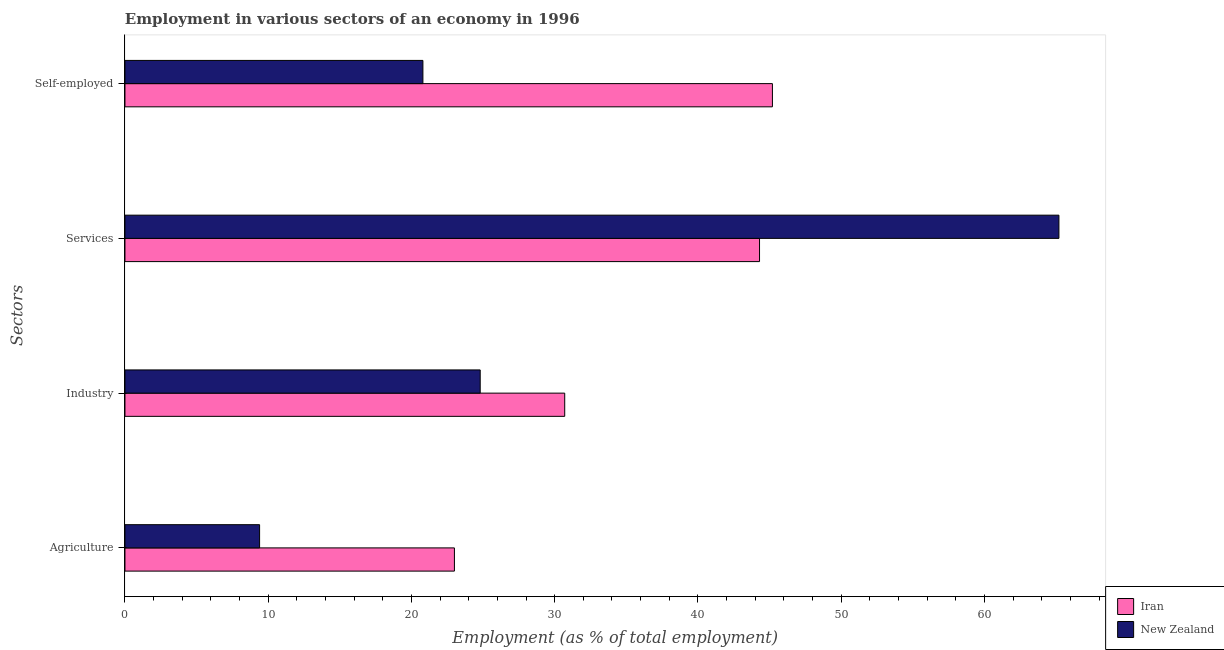How many groups of bars are there?
Give a very brief answer. 4. Are the number of bars per tick equal to the number of legend labels?
Provide a succinct answer. Yes. Are the number of bars on each tick of the Y-axis equal?
Your answer should be very brief. Yes. How many bars are there on the 3rd tick from the top?
Provide a succinct answer. 2. What is the label of the 1st group of bars from the top?
Make the answer very short. Self-employed. What is the percentage of workers in industry in New Zealand?
Your answer should be very brief. 24.8. Across all countries, what is the maximum percentage of workers in services?
Make the answer very short. 65.2. Across all countries, what is the minimum percentage of workers in services?
Provide a short and direct response. 44.3. In which country was the percentage of workers in industry maximum?
Offer a terse response. Iran. In which country was the percentage of workers in industry minimum?
Your response must be concise. New Zealand. What is the total percentage of workers in agriculture in the graph?
Your answer should be very brief. 32.4. What is the difference between the percentage of workers in agriculture in New Zealand and that in Iran?
Make the answer very short. -13.6. What is the difference between the percentage of workers in services in New Zealand and the percentage of workers in agriculture in Iran?
Offer a terse response. 42.2. What is the average percentage of workers in services per country?
Offer a very short reply. 54.75. What is the difference between the percentage of workers in industry and percentage of self employed workers in Iran?
Keep it short and to the point. -14.5. What is the ratio of the percentage of workers in services in New Zealand to that in Iran?
Provide a short and direct response. 1.47. Is the percentage of workers in industry in Iran less than that in New Zealand?
Offer a very short reply. No. Is the difference between the percentage of workers in services in Iran and New Zealand greater than the difference between the percentage of workers in agriculture in Iran and New Zealand?
Provide a short and direct response. No. What is the difference between the highest and the second highest percentage of workers in industry?
Your answer should be very brief. 5.9. What is the difference between the highest and the lowest percentage of workers in industry?
Your answer should be compact. 5.9. In how many countries, is the percentage of workers in industry greater than the average percentage of workers in industry taken over all countries?
Ensure brevity in your answer.  1. Is the sum of the percentage of self employed workers in Iran and New Zealand greater than the maximum percentage of workers in industry across all countries?
Give a very brief answer. Yes. What does the 2nd bar from the top in Industry represents?
Provide a short and direct response. Iran. What does the 2nd bar from the bottom in Industry represents?
Keep it short and to the point. New Zealand. How many bars are there?
Ensure brevity in your answer.  8. Are all the bars in the graph horizontal?
Ensure brevity in your answer.  Yes. What is the difference between two consecutive major ticks on the X-axis?
Keep it short and to the point. 10. Are the values on the major ticks of X-axis written in scientific E-notation?
Provide a short and direct response. No. Where does the legend appear in the graph?
Offer a terse response. Bottom right. How many legend labels are there?
Ensure brevity in your answer.  2. What is the title of the graph?
Ensure brevity in your answer.  Employment in various sectors of an economy in 1996. Does "Costa Rica" appear as one of the legend labels in the graph?
Your answer should be very brief. No. What is the label or title of the X-axis?
Make the answer very short. Employment (as % of total employment). What is the label or title of the Y-axis?
Make the answer very short. Sectors. What is the Employment (as % of total employment) in New Zealand in Agriculture?
Your answer should be compact. 9.4. What is the Employment (as % of total employment) in Iran in Industry?
Your response must be concise. 30.7. What is the Employment (as % of total employment) of New Zealand in Industry?
Your answer should be very brief. 24.8. What is the Employment (as % of total employment) in Iran in Services?
Your answer should be compact. 44.3. What is the Employment (as % of total employment) in New Zealand in Services?
Your answer should be very brief. 65.2. What is the Employment (as % of total employment) of Iran in Self-employed?
Offer a terse response. 45.2. What is the Employment (as % of total employment) of New Zealand in Self-employed?
Keep it short and to the point. 20.8. Across all Sectors, what is the maximum Employment (as % of total employment) in Iran?
Offer a terse response. 45.2. Across all Sectors, what is the maximum Employment (as % of total employment) of New Zealand?
Provide a short and direct response. 65.2. Across all Sectors, what is the minimum Employment (as % of total employment) in New Zealand?
Your answer should be compact. 9.4. What is the total Employment (as % of total employment) in Iran in the graph?
Offer a terse response. 143.2. What is the total Employment (as % of total employment) of New Zealand in the graph?
Offer a terse response. 120.2. What is the difference between the Employment (as % of total employment) of New Zealand in Agriculture and that in Industry?
Ensure brevity in your answer.  -15.4. What is the difference between the Employment (as % of total employment) in Iran in Agriculture and that in Services?
Make the answer very short. -21.3. What is the difference between the Employment (as % of total employment) in New Zealand in Agriculture and that in Services?
Give a very brief answer. -55.8. What is the difference between the Employment (as % of total employment) of Iran in Agriculture and that in Self-employed?
Offer a very short reply. -22.2. What is the difference between the Employment (as % of total employment) in New Zealand in Agriculture and that in Self-employed?
Provide a succinct answer. -11.4. What is the difference between the Employment (as % of total employment) of New Zealand in Industry and that in Services?
Offer a very short reply. -40.4. What is the difference between the Employment (as % of total employment) of Iran in Industry and that in Self-employed?
Your response must be concise. -14.5. What is the difference between the Employment (as % of total employment) of Iran in Services and that in Self-employed?
Your response must be concise. -0.9. What is the difference between the Employment (as % of total employment) of New Zealand in Services and that in Self-employed?
Offer a very short reply. 44.4. What is the difference between the Employment (as % of total employment) of Iran in Agriculture and the Employment (as % of total employment) of New Zealand in Services?
Your answer should be compact. -42.2. What is the difference between the Employment (as % of total employment) in Iran in Agriculture and the Employment (as % of total employment) in New Zealand in Self-employed?
Provide a succinct answer. 2.2. What is the difference between the Employment (as % of total employment) in Iran in Industry and the Employment (as % of total employment) in New Zealand in Services?
Ensure brevity in your answer.  -34.5. What is the difference between the Employment (as % of total employment) in Iran in Services and the Employment (as % of total employment) in New Zealand in Self-employed?
Make the answer very short. 23.5. What is the average Employment (as % of total employment) of Iran per Sectors?
Give a very brief answer. 35.8. What is the average Employment (as % of total employment) in New Zealand per Sectors?
Make the answer very short. 30.05. What is the difference between the Employment (as % of total employment) of Iran and Employment (as % of total employment) of New Zealand in Agriculture?
Your answer should be compact. 13.6. What is the difference between the Employment (as % of total employment) in Iran and Employment (as % of total employment) in New Zealand in Services?
Give a very brief answer. -20.9. What is the difference between the Employment (as % of total employment) in Iran and Employment (as % of total employment) in New Zealand in Self-employed?
Ensure brevity in your answer.  24.4. What is the ratio of the Employment (as % of total employment) of Iran in Agriculture to that in Industry?
Make the answer very short. 0.75. What is the ratio of the Employment (as % of total employment) in New Zealand in Agriculture to that in Industry?
Provide a short and direct response. 0.38. What is the ratio of the Employment (as % of total employment) in Iran in Agriculture to that in Services?
Your response must be concise. 0.52. What is the ratio of the Employment (as % of total employment) of New Zealand in Agriculture to that in Services?
Offer a terse response. 0.14. What is the ratio of the Employment (as % of total employment) in Iran in Agriculture to that in Self-employed?
Provide a succinct answer. 0.51. What is the ratio of the Employment (as % of total employment) in New Zealand in Agriculture to that in Self-employed?
Keep it short and to the point. 0.45. What is the ratio of the Employment (as % of total employment) of Iran in Industry to that in Services?
Keep it short and to the point. 0.69. What is the ratio of the Employment (as % of total employment) in New Zealand in Industry to that in Services?
Provide a short and direct response. 0.38. What is the ratio of the Employment (as % of total employment) in Iran in Industry to that in Self-employed?
Give a very brief answer. 0.68. What is the ratio of the Employment (as % of total employment) of New Zealand in Industry to that in Self-employed?
Your answer should be compact. 1.19. What is the ratio of the Employment (as % of total employment) of Iran in Services to that in Self-employed?
Provide a succinct answer. 0.98. What is the ratio of the Employment (as % of total employment) of New Zealand in Services to that in Self-employed?
Your answer should be compact. 3.13. What is the difference between the highest and the second highest Employment (as % of total employment) of New Zealand?
Offer a terse response. 40.4. What is the difference between the highest and the lowest Employment (as % of total employment) of Iran?
Keep it short and to the point. 22.2. What is the difference between the highest and the lowest Employment (as % of total employment) in New Zealand?
Ensure brevity in your answer.  55.8. 